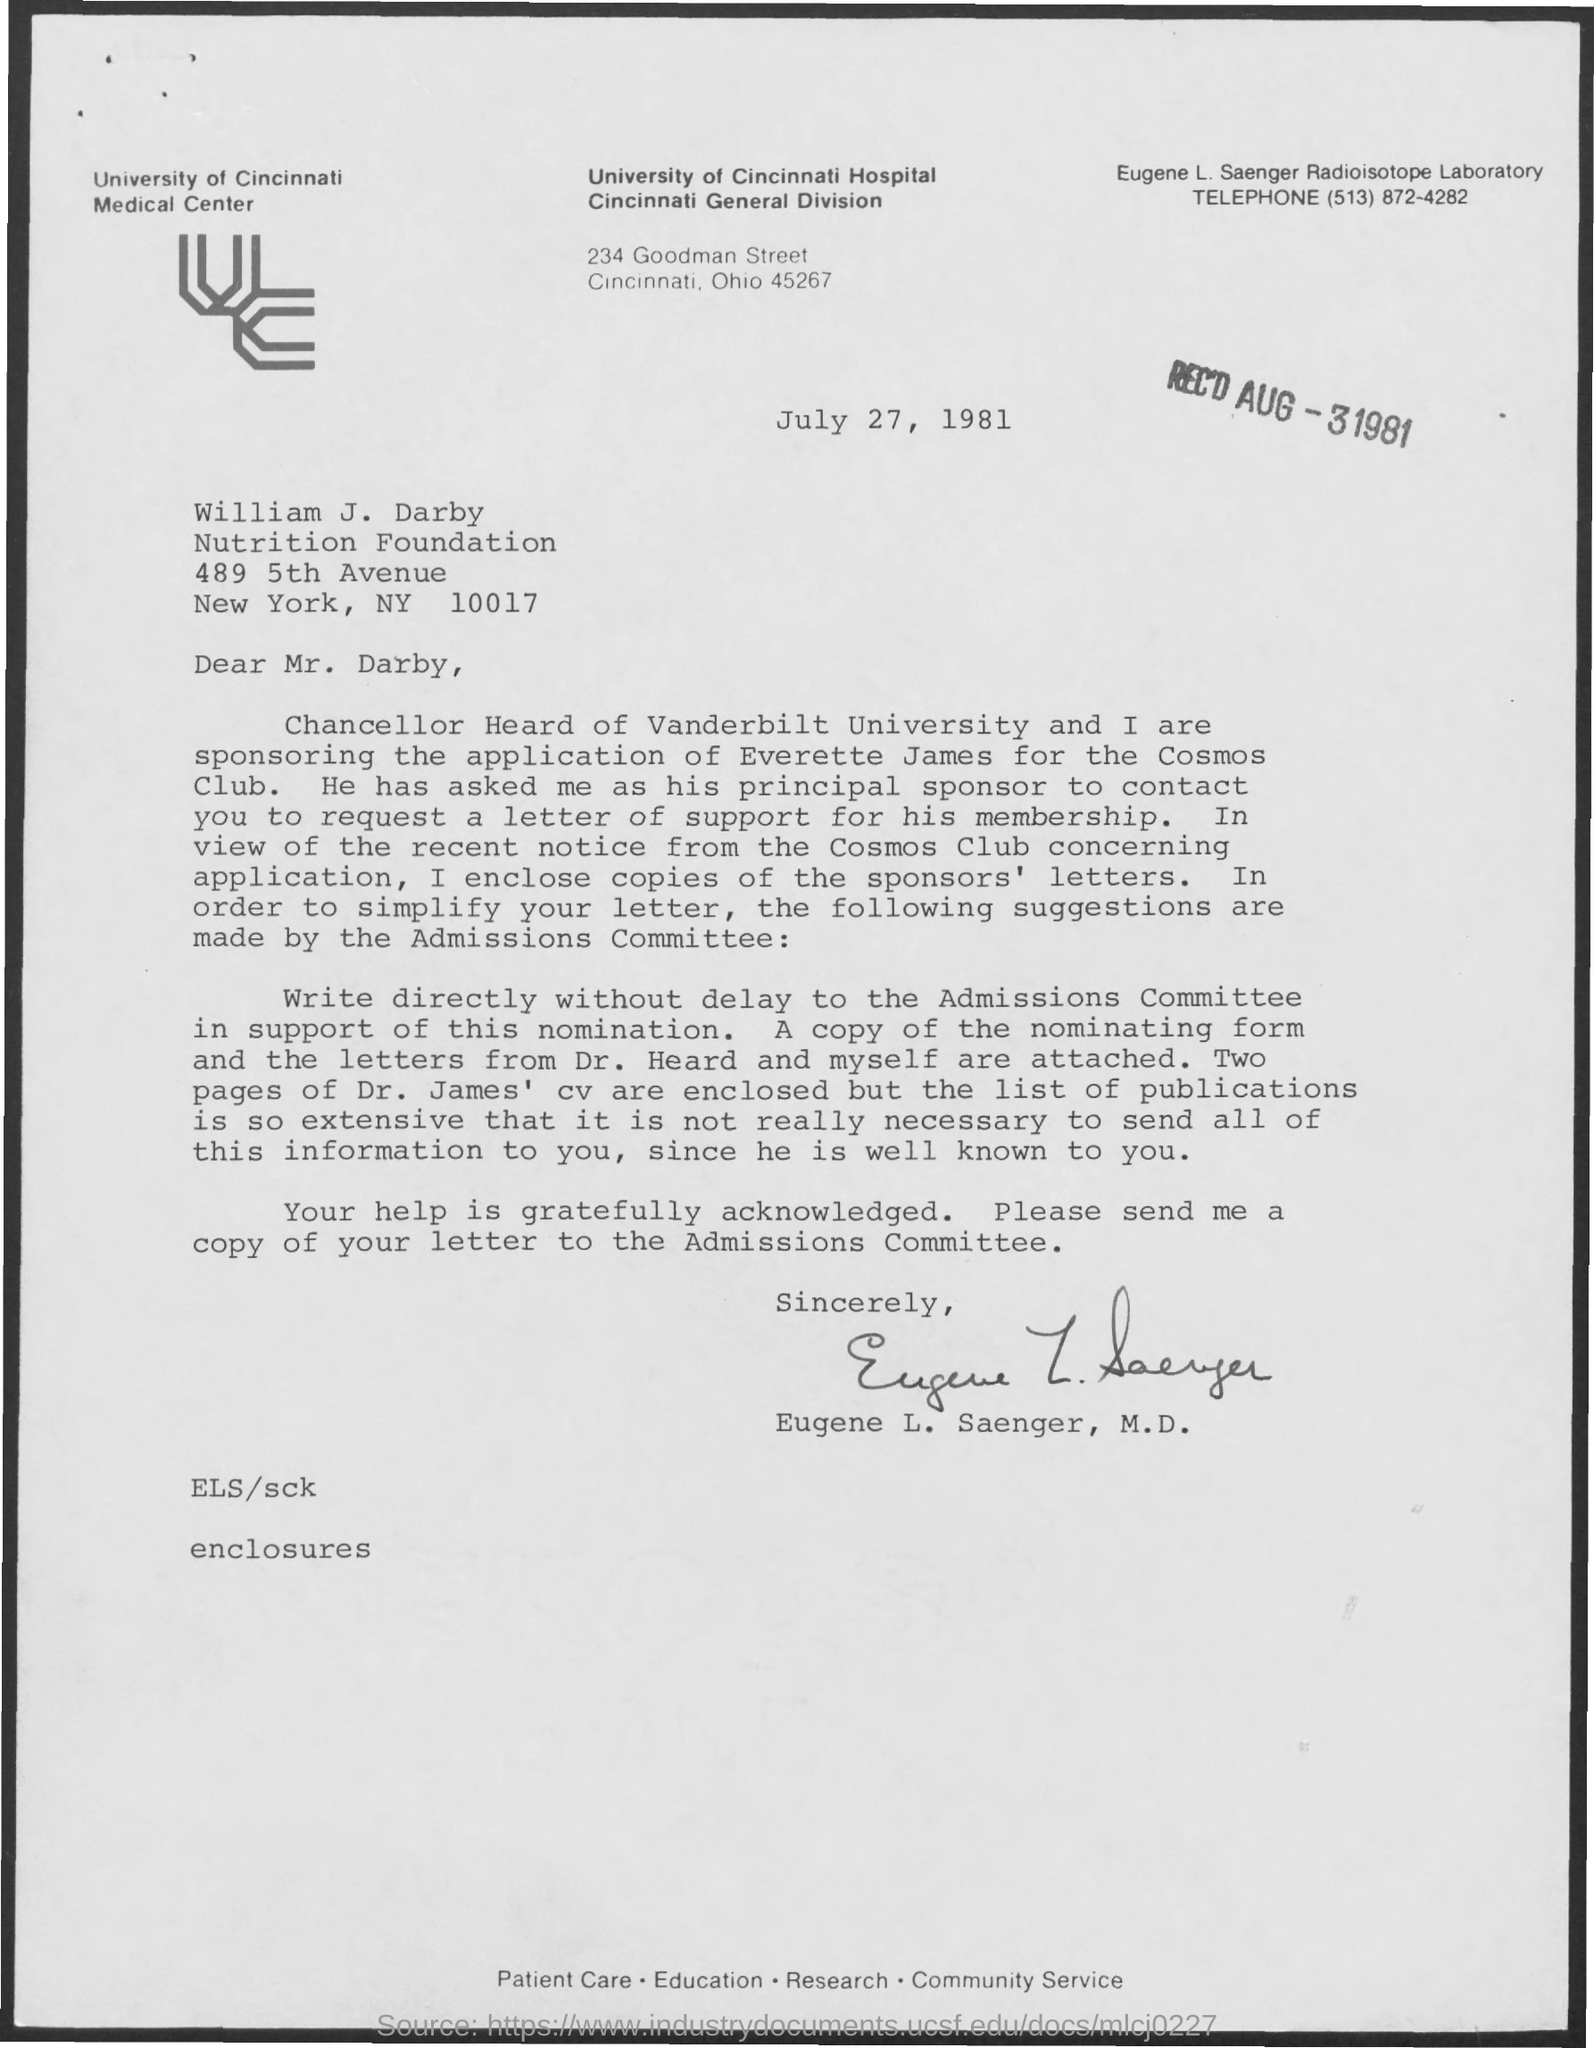What is the name of the university ?
Your answer should be very brief. University of Cincinnati Hospital. What is the date mentioned ?
Provide a succinct answer. July 27 ,1981. What is the rec'd  date mentioned ?
Your answer should be very brief. AUG-3 1981. To whom this letter is written
Provide a succinct answer. Mr. Darby. This letter is written by whom
Keep it short and to the point. Eugene L. Saenger, M.D. In which state and city university of cincinnati hospital located ?
Offer a terse response. Cincinnati , Ohio. 